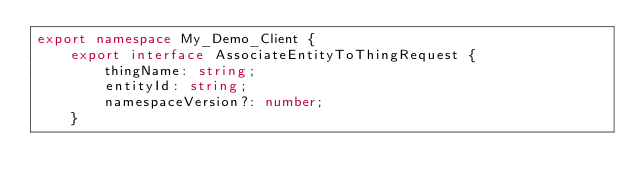Convert code to text. <code><loc_0><loc_0><loc_500><loc_500><_TypeScript_>export namespace My_Demo_Client {
	export interface AssociateEntityToThingRequest {
		thingName: string;
		entityId: string;
		namespaceVersion?: number;
	}
</code> 